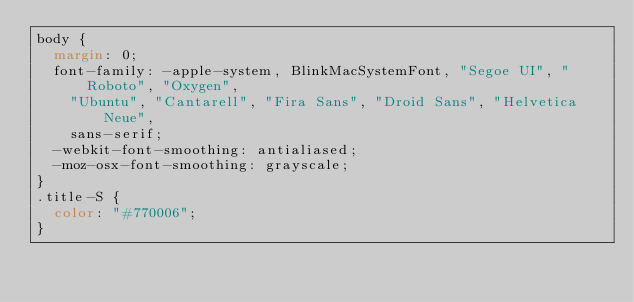<code> <loc_0><loc_0><loc_500><loc_500><_CSS_>body {
  margin: 0;
  font-family: -apple-system, BlinkMacSystemFont, "Segoe UI", "Roboto", "Oxygen",
    "Ubuntu", "Cantarell", "Fira Sans", "Droid Sans", "Helvetica Neue",
    sans-serif;
  -webkit-font-smoothing: antialiased;
  -moz-osx-font-smoothing: grayscale;
}
.title-S {
  color: "#770006";
}
</code> 